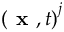<formula> <loc_0><loc_0><loc_500><loc_500>\left ( x , t \right ) ^ { j }</formula> 